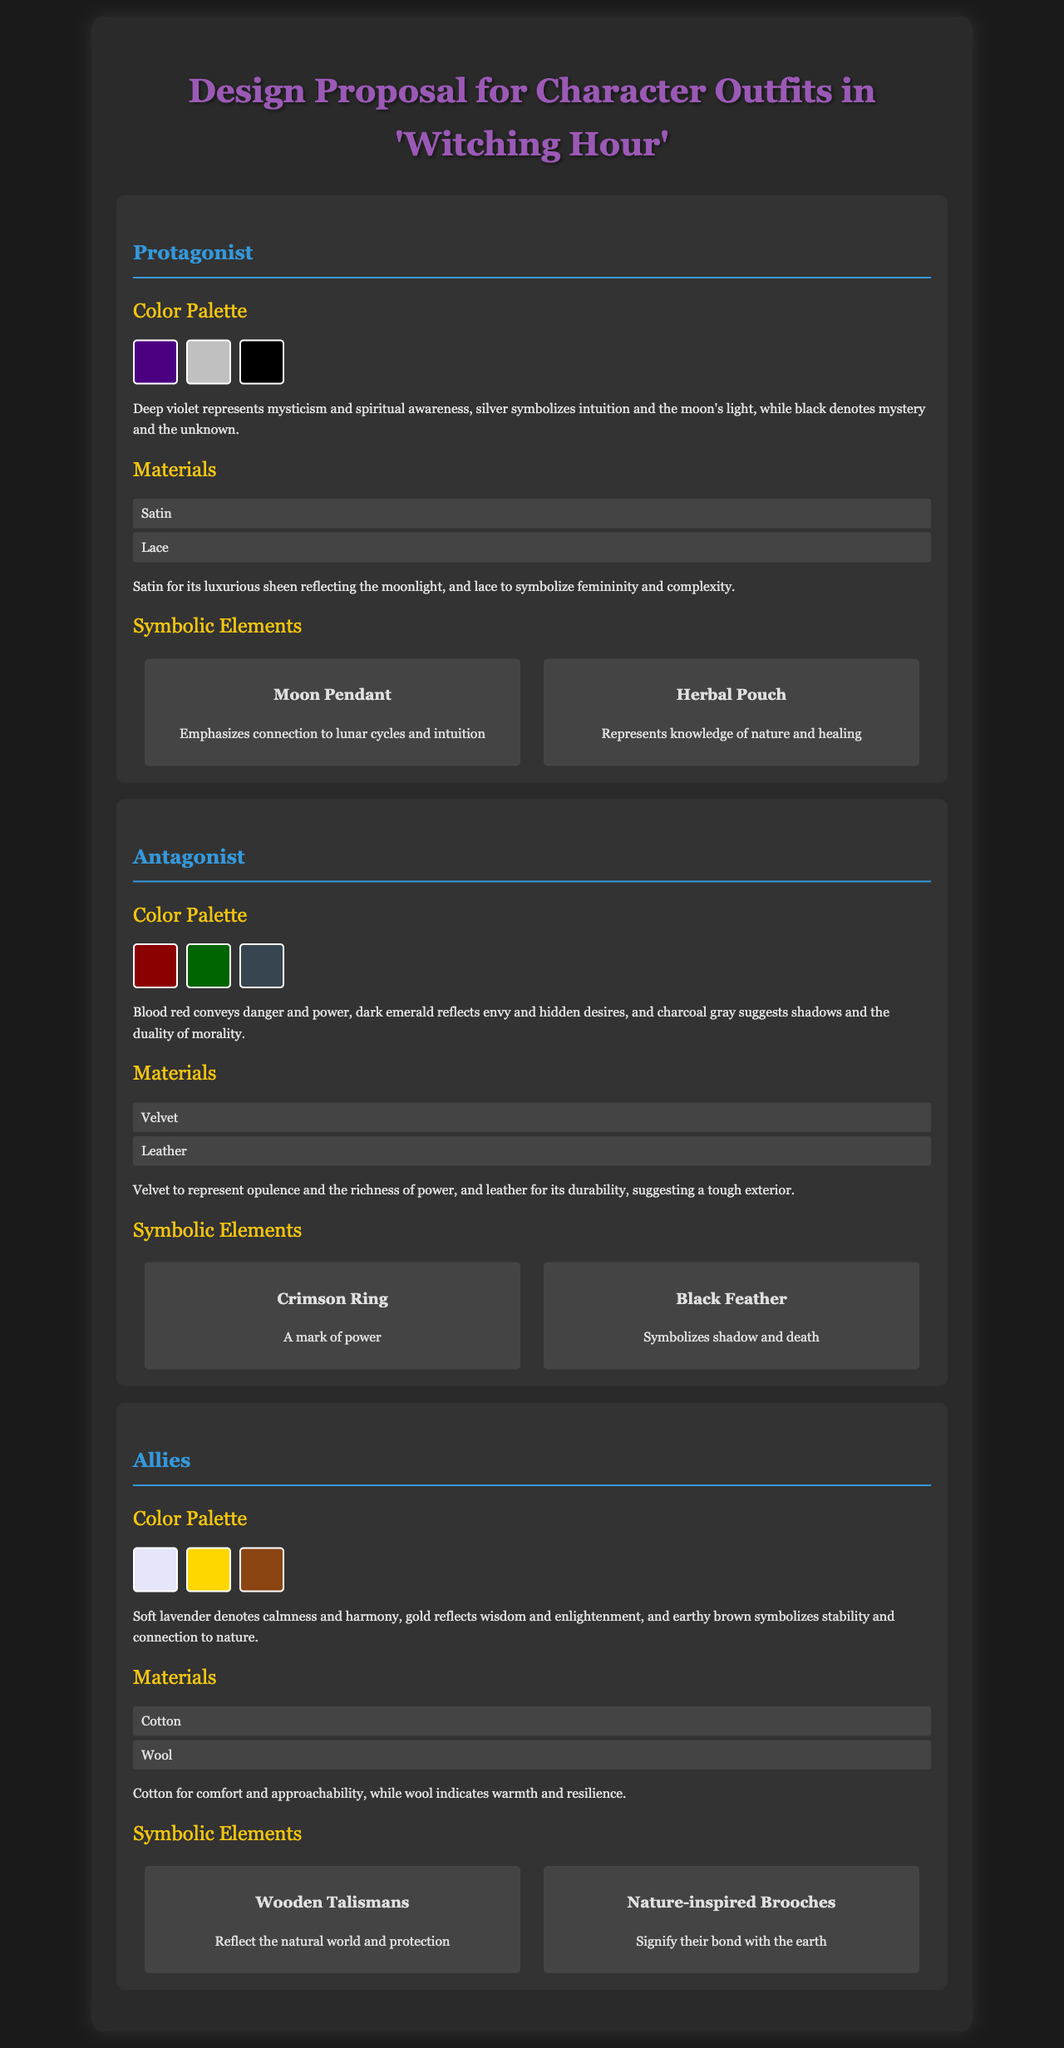What is the color representing mysticism? The document states that deep violet represents mysticism and spiritual awareness.
Answer: Deep violet What is the fabric used for the protagonist's outfit? The protagonist's outfit includes satin and lace as materials.
Answer: Satin, Lace What color indicates danger for the antagonist? Blood red conveys danger and power in the antagonist's palette.
Answer: Blood red What accessory represents knowledge of nature for the protagonist? The herbal pouch emphasizes connection to nature and healing.
Answer: Herbal Pouch What color symbolizes stability for the allies? Earthy brown in the allies' palette symbolizes stability and connection to nature.
Answer: Earthy brown How many colors are in the allies' color palette? The allies' palette contains three colors as listed in the document.
Answer: Three What material signifies warmth in the allies' outfits? The document mentions wool as a material indicating warmth and resilience.
Answer: Wool What symbolic element is associated with shadow for the antagonist? The black feather symbolizes shadow and death in the antagonist's outfit.
Answer: Black Feather What is the primary color used in the protagonist's color palette? The primary color reflecting the protagonist’s identity is deep violet.
Answer: Deep violet 